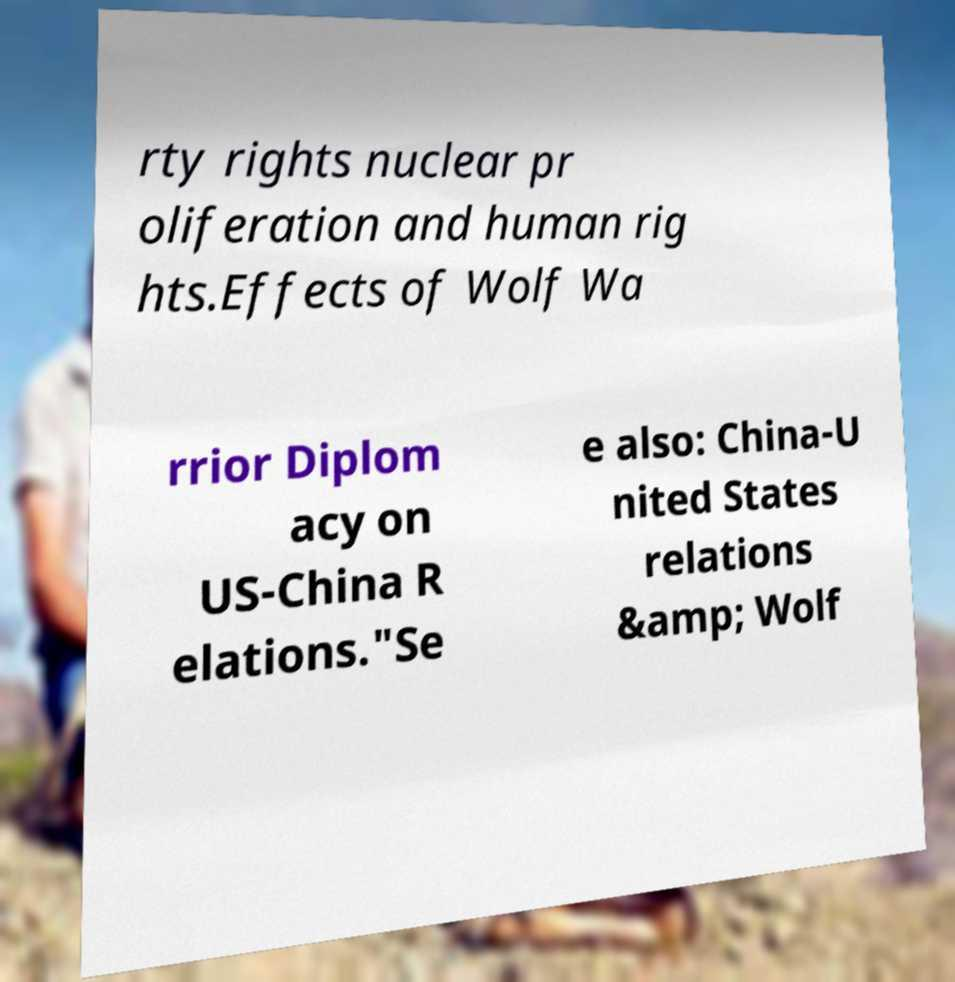Could you assist in decoding the text presented in this image and type it out clearly? rty rights nuclear pr oliferation and human rig hts.Effects of Wolf Wa rrior Diplom acy on US-China R elations."Se e also: China-U nited States relations &amp; Wolf 